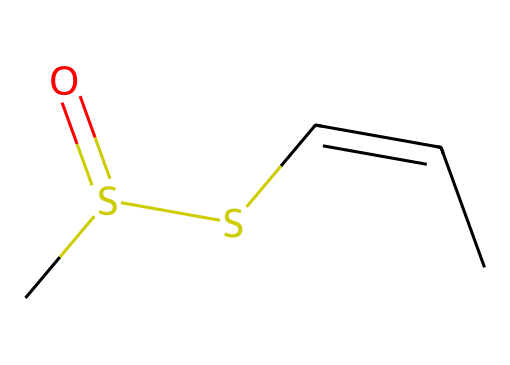What is the formula of allicin? To determine the chemical formula, we identify the atoms present in the SMILES representation. The SMILES indicates carbon (C), sulfur (S), and oxygen (O) atoms. Counting from the structure, we find there are 6 carbon atoms, 2 sulfur atoms, and 1 oxygen atom. Thus, the formula is C6H10O1S2.
Answer: C6H10O1S2 How many sulfur atoms does allicin contain? By examining the SMILES representation, it shows two "S" characters indicating the presence of sulfur atoms. Therefore, the count of sulfur atoms is simply the number of "S" in the structure.
Answer: 2 What type of chemical compound is allicin? Allicin is classified as a thioether due to its structural features, which include sulfur atoms bonded to carbon and a double bond in the carbon chain. Its specific properties place it within organosulfur compounds.
Answer: thioether Is there a double bond present in allicin? In the SMILES notation, "/C=C\" indicates the presence of a double bond between two carbon atoms. This means there is indeed a double bond within the molecular structure of allicin.
Answer: Yes What functional groups are present in allicin? Examining the structure indicated by the SMILES, we identify the following functional groups: there are thiol (due to the sulfur atoms) and alkene (due to the double bond). These functional groups are critical to its chemical behavior.
Answer: thiol and alkene 